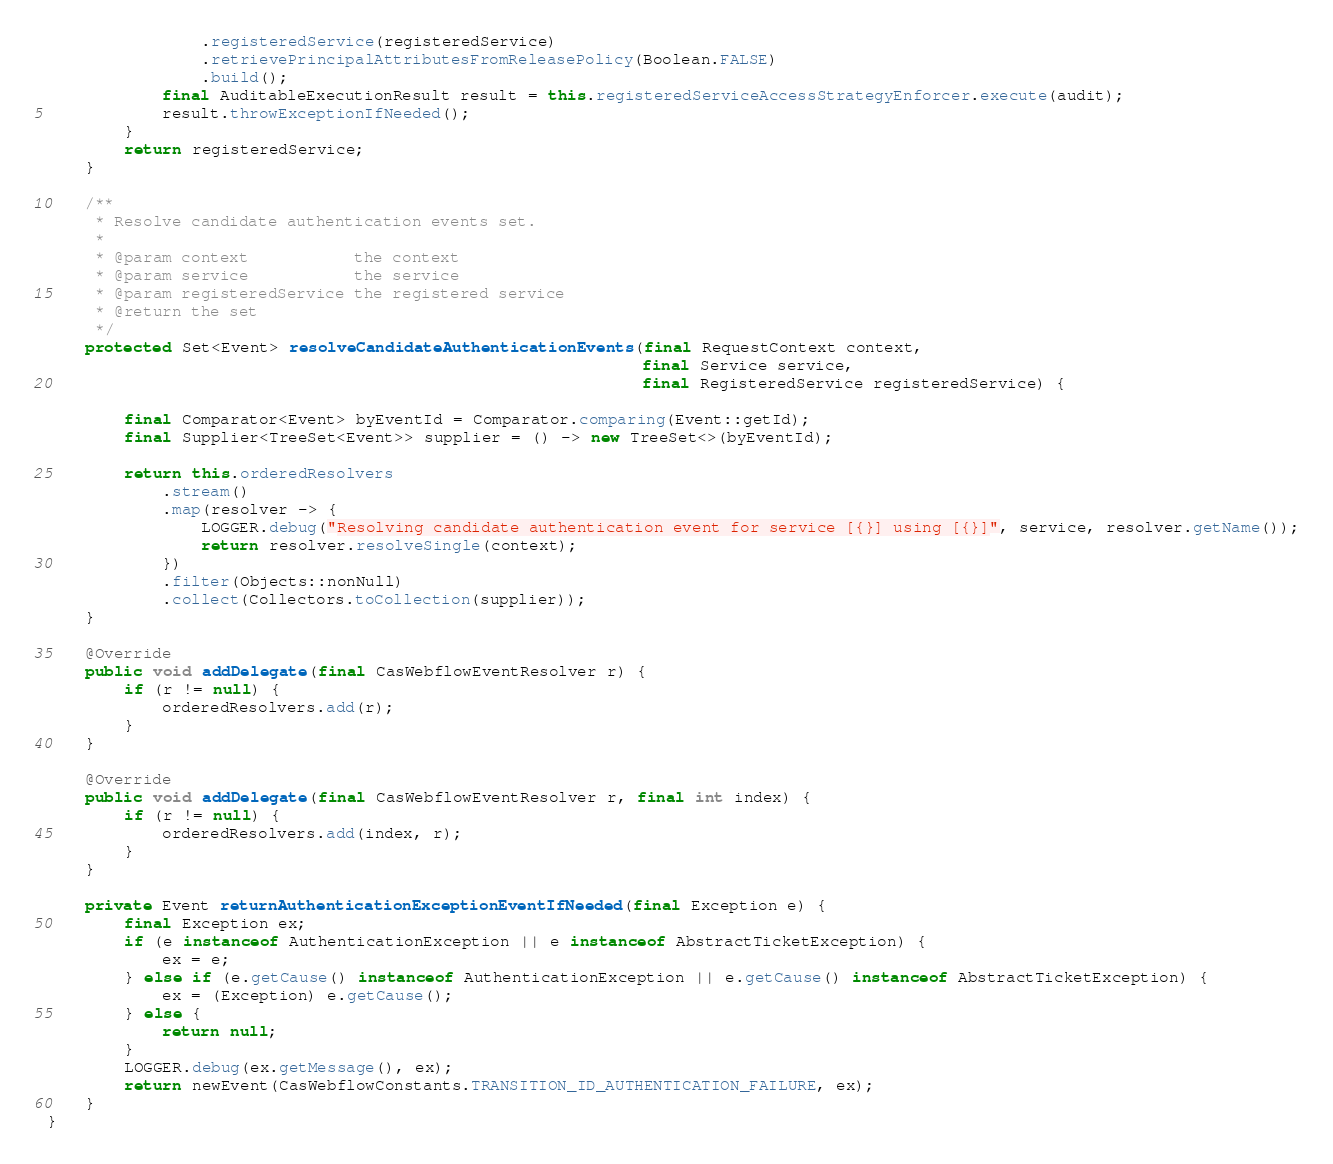<code> <loc_0><loc_0><loc_500><loc_500><_Java_>                .registeredService(registeredService)
                .retrievePrincipalAttributesFromReleasePolicy(Boolean.FALSE)
                .build();
            final AuditableExecutionResult result = this.registeredServiceAccessStrategyEnforcer.execute(audit);
            result.throwExceptionIfNeeded();
        }
        return registeredService;
    }

    /**
     * Resolve candidate authentication events set.
     *
     * @param context           the context
     * @param service           the service
     * @param registeredService the registered service
     * @return the set
     */
    protected Set<Event> resolveCandidateAuthenticationEvents(final RequestContext context,
                                                              final Service service,
                                                              final RegisteredService registeredService) {

        final Comparator<Event> byEventId = Comparator.comparing(Event::getId);
        final Supplier<TreeSet<Event>> supplier = () -> new TreeSet<>(byEventId);

        return this.orderedResolvers
            .stream()
            .map(resolver -> {
                LOGGER.debug("Resolving candidate authentication event for service [{}] using [{}]", service, resolver.getName());
                return resolver.resolveSingle(context);
            })
            .filter(Objects::nonNull)
            .collect(Collectors.toCollection(supplier));
    }

    @Override
    public void addDelegate(final CasWebflowEventResolver r) {
        if (r != null) {
            orderedResolvers.add(r);
        }
    }

    @Override
    public void addDelegate(final CasWebflowEventResolver r, final int index) {
        if (r != null) {
            orderedResolvers.add(index, r);
        }
    }

    private Event returnAuthenticationExceptionEventIfNeeded(final Exception e) {
        final Exception ex;
        if (e instanceof AuthenticationException || e instanceof AbstractTicketException) {
            ex = e;
        } else if (e.getCause() instanceof AuthenticationException || e.getCause() instanceof AbstractTicketException) {
            ex = (Exception) e.getCause();
        } else {
            return null;
        }
        LOGGER.debug(ex.getMessage(), ex);
        return newEvent(CasWebflowConstants.TRANSITION_ID_AUTHENTICATION_FAILURE, ex);
    }
}
</code> 